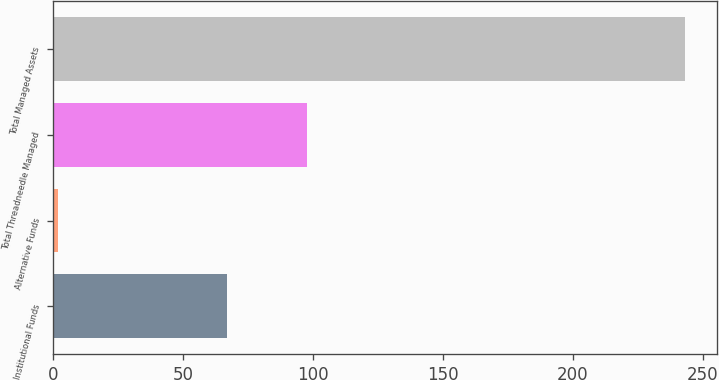Convert chart to OTSL. <chart><loc_0><loc_0><loc_500><loc_500><bar_chart><fcel>Institutional Funds<fcel>Alternative Funds<fcel>Total Threadneedle Managed<fcel>Total Managed Assets<nl><fcel>66.8<fcel>1.9<fcel>97.8<fcel>243.2<nl></chart> 